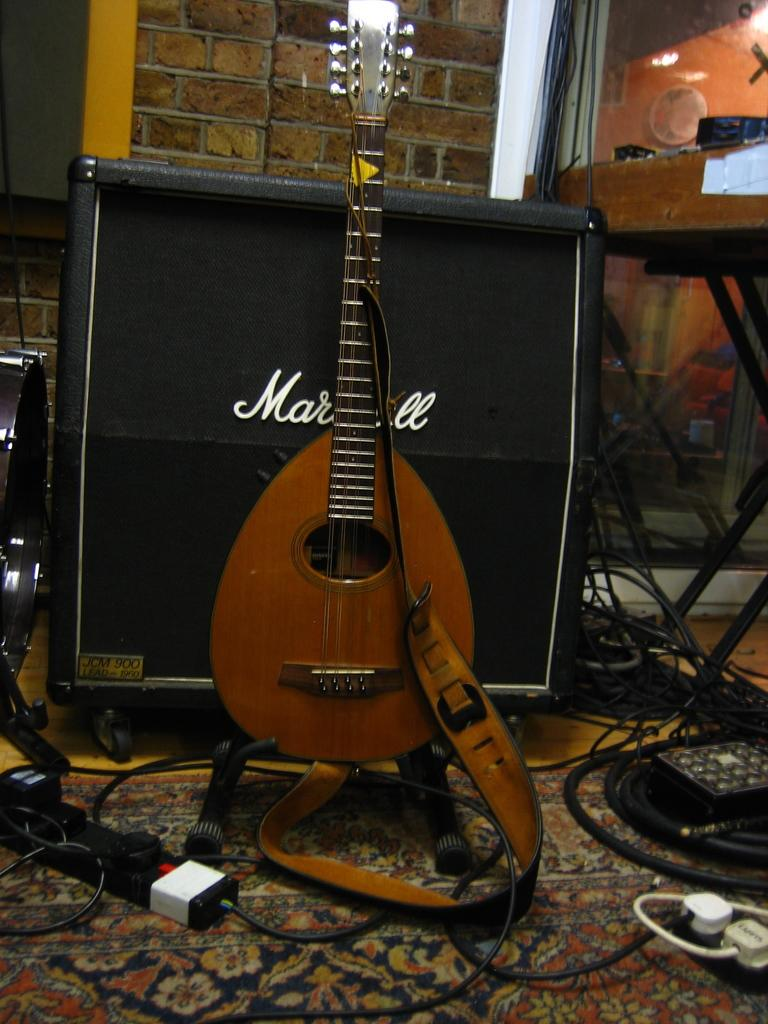What musical instrument is present in the image? There is a guitar in the image. What device might be used to amplify sound in the image? There is a speaker in the image. What connects the guitar and speaker in the image? Wires are visible in the image, connecting the guitar and speaker. How many ladybugs can be seen on the guitar in the image? There are no ladybugs present in the image; it features a guitar, speaker, and wires. What type of fowl is sitting on the speaker in the image? There is no fowl present in the image; it only features a guitar, speaker, and wires. 